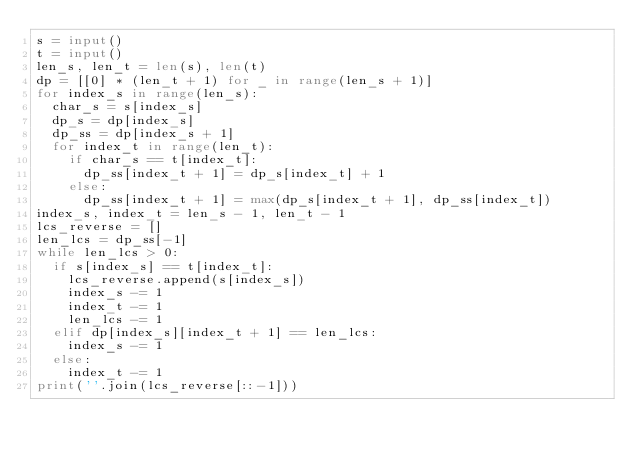Convert code to text. <code><loc_0><loc_0><loc_500><loc_500><_Python_>s = input()
t = input()
len_s, len_t = len(s), len(t)
dp = [[0] * (len_t + 1) for _ in range(len_s + 1)]
for index_s in range(len_s):
  char_s = s[index_s]
  dp_s = dp[index_s]
  dp_ss = dp[index_s + 1]
  for index_t in range(len_t):
    if char_s == t[index_t]:
      dp_ss[index_t + 1] = dp_s[index_t] + 1
    else:
      dp_ss[index_t + 1] = max(dp_s[index_t + 1], dp_ss[index_t])
index_s, index_t = len_s - 1, len_t - 1
lcs_reverse = []
len_lcs = dp_ss[-1]
while len_lcs > 0:
  if s[index_s] == t[index_t]:
    lcs_reverse.append(s[index_s])
    index_s -= 1
    index_t -= 1
    len_lcs -= 1
  elif dp[index_s][index_t + 1] == len_lcs:
    index_s -= 1
  else:
    index_t -= 1
print(''.join(lcs_reverse[::-1]))</code> 